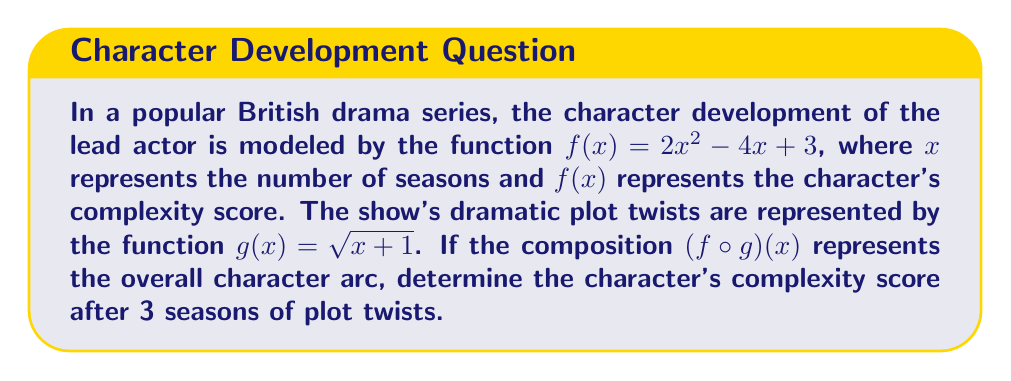Solve this math problem. To solve this problem, we need to follow these steps:

1) First, we need to understand what $(f \circ g)(x)$ means. This is a composition of functions where we apply $g(x)$ first, and then apply $f(x)$ to the result.

2) We're asked about the complexity score after 3 seasons, so we need to calculate $(f \circ g)(3)$.

3) Let's start by calculating $g(3)$:
   $g(3) = \sqrt{3+1} = \sqrt{4} = 2$

4) Now we need to calculate $f(2)$, because $g(3) = 2$:
   $f(2) = 2(2)^2 - 4(2) + 3$

5) Let's solve this step-by-step:
   $f(2) = 2(4) - 8 + 3$
   $f(2) = 8 - 8 + 3$
   $f(2) = 3$

6) Therefore, $(f \circ g)(3) = f(g(3)) = f(2) = 3$

This result means that after 3 seasons of plot twists, the character's complexity score is 3.
Answer: 3 